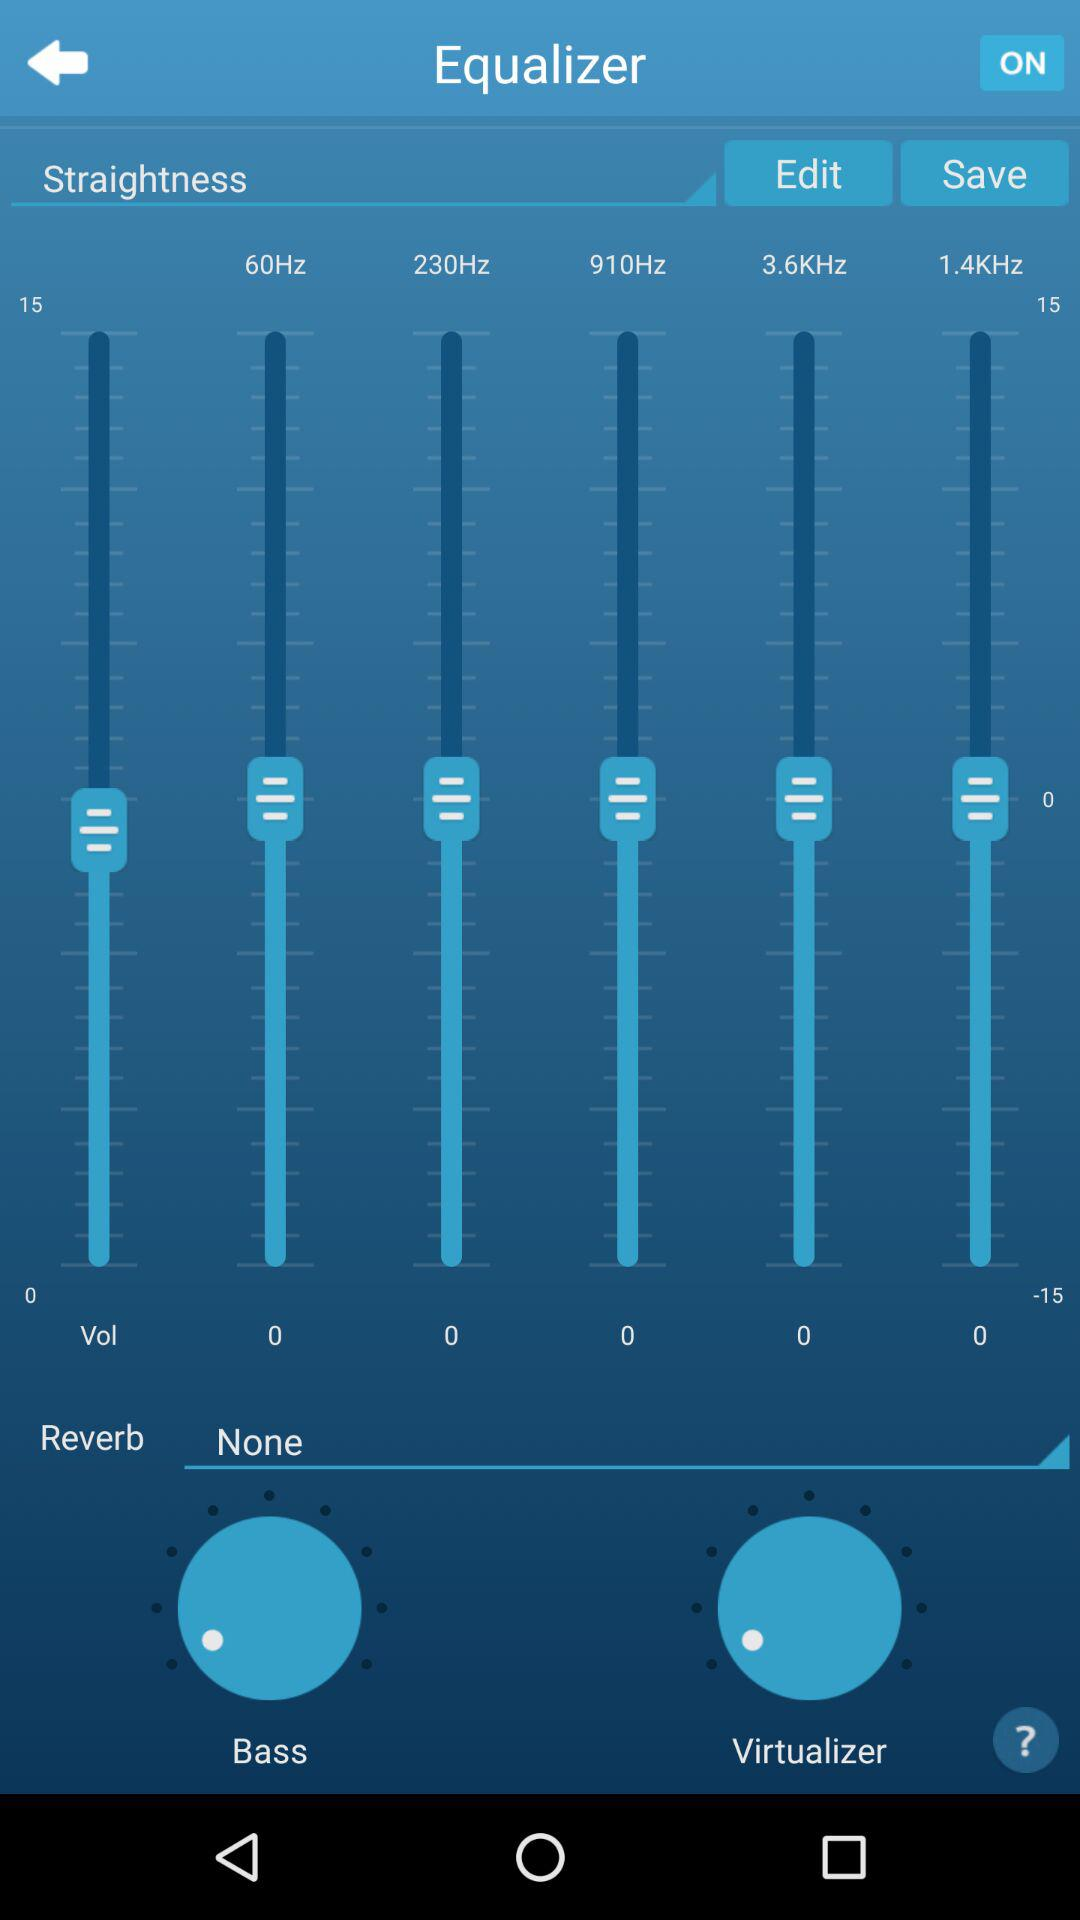What is the status of the "Equalizer"? The status is "on". 